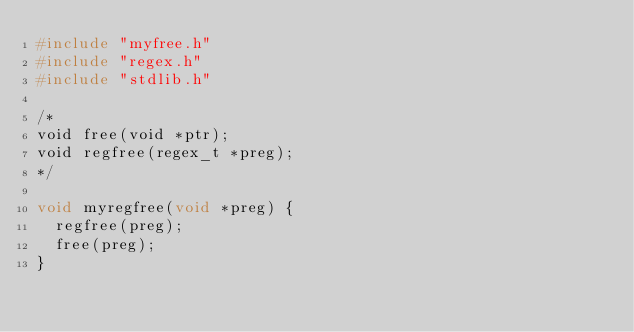<code> <loc_0><loc_0><loc_500><loc_500><_C_>#include "myfree.h"
#include "regex.h"
#include "stdlib.h"

/* 
void free(void *ptr);
void regfree(regex_t *preg);
*/

void myregfree(void *preg) {
  regfree(preg);
  free(preg);
}
</code> 